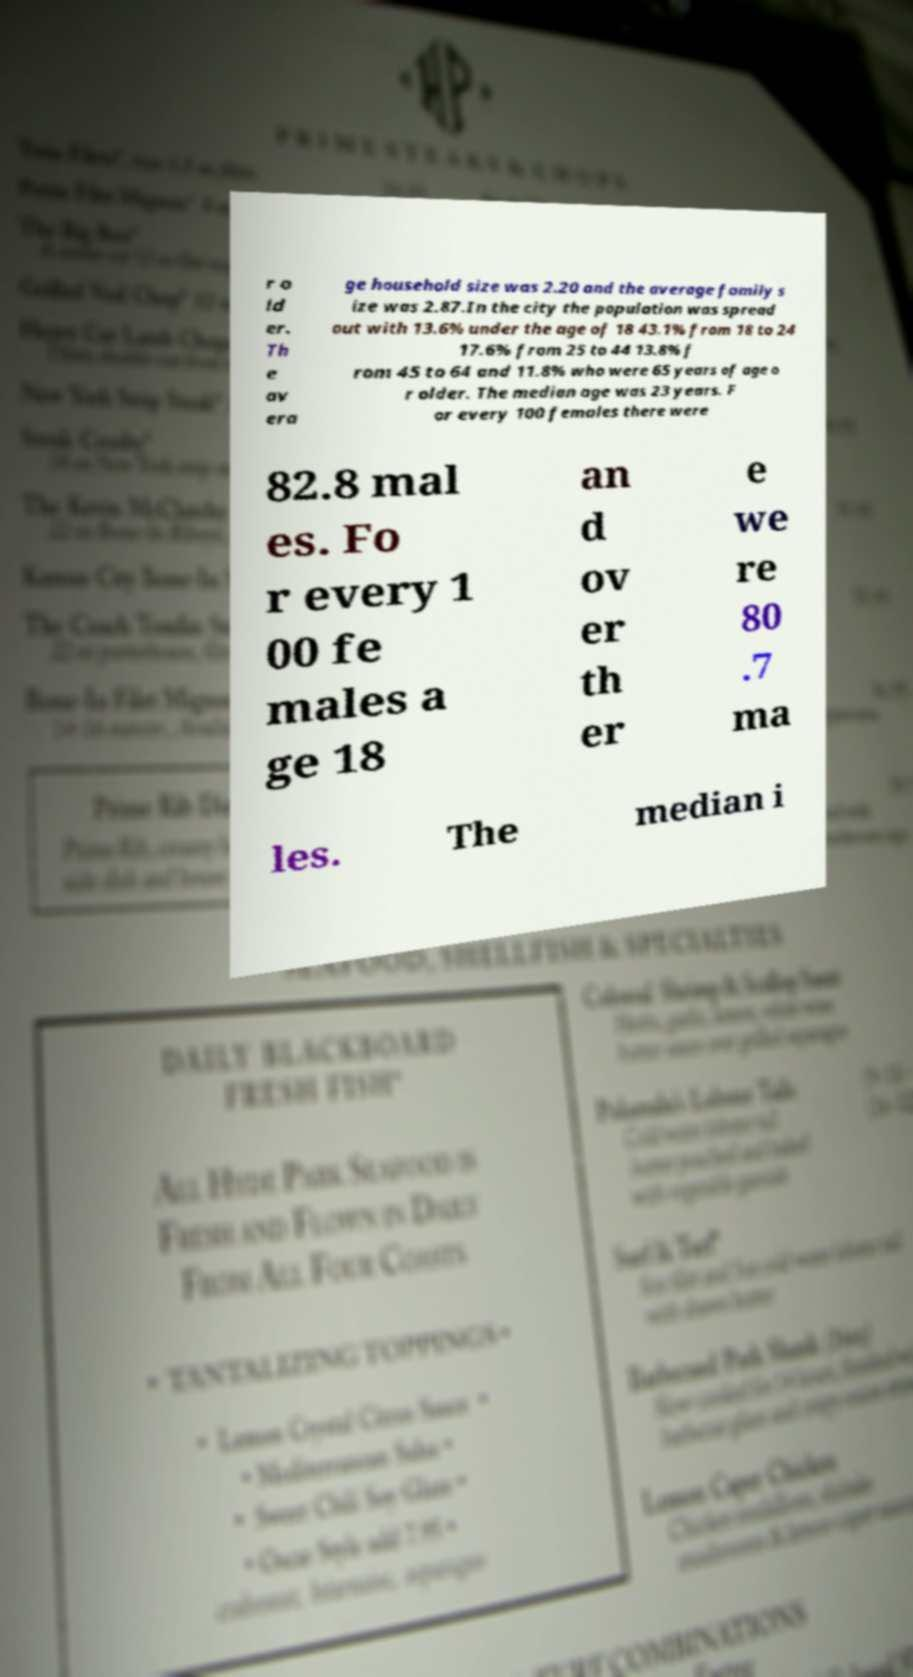Please read and relay the text visible in this image. What does it say? r o ld er. Th e av era ge household size was 2.20 and the average family s ize was 2.87.In the city the population was spread out with 13.6% under the age of 18 43.1% from 18 to 24 17.6% from 25 to 44 13.8% f rom 45 to 64 and 11.8% who were 65 years of age o r older. The median age was 23 years. F or every 100 females there were 82.8 mal es. Fo r every 1 00 fe males a ge 18 an d ov er th er e we re 80 .7 ma les. The median i 